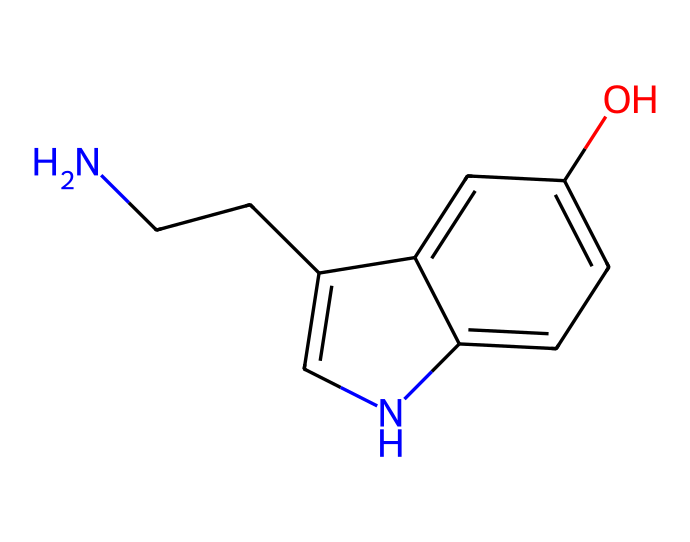What is the molecular formula of this compound? To determine the molecular formula, count the number of each type of atom in the SMILES representation. Here, there are 10 carbon atoms (C), 12 hydrogen atoms (H), 1 nitrogen atom (N), and 1 oxygen atom (O). Thus, the molecular formula becomes C10H12N2O.
Answer: C10H12N2O How many rings are present in the structure? Examine the chemical structure to identify closed loops; the structure shows two interconnected rings formed by the c1c[nH]c and c2cc compounds. Hence, there are 2 rings in total.
Answer: 2 What functional group is featured in this molecule? Look for specific groups of atoms that characterize the chemical; the presence of the -OH group tells us that this molecule contains a phenolic hydroxyl functional group.
Answer: hydroxyl Which atom is responsible for the basic properties of this compound? The nitrogen atom present in the structure typically contributes to basic properties due to its ability to accept protons. Thus, it significantly influences the compound's basic characteristics.
Answer: nitrogen How many aromatic rings are there in this chemical? Analyzing the structure, we can identify that there are two benzene-like structures which are considered aromatic; therefore, it indicates the presence of 2 aromatic rings in the compound.
Answer: 2 What does the presence of the nitrogen atom indicate about its function in the body? Nitrogen often signifies the presence of amines or amides, which are crucial for the functions of neurotransmitters. In this case, nitrogen's role is essential for serotonin's function in mood regulation.
Answer: neurotransmitter 